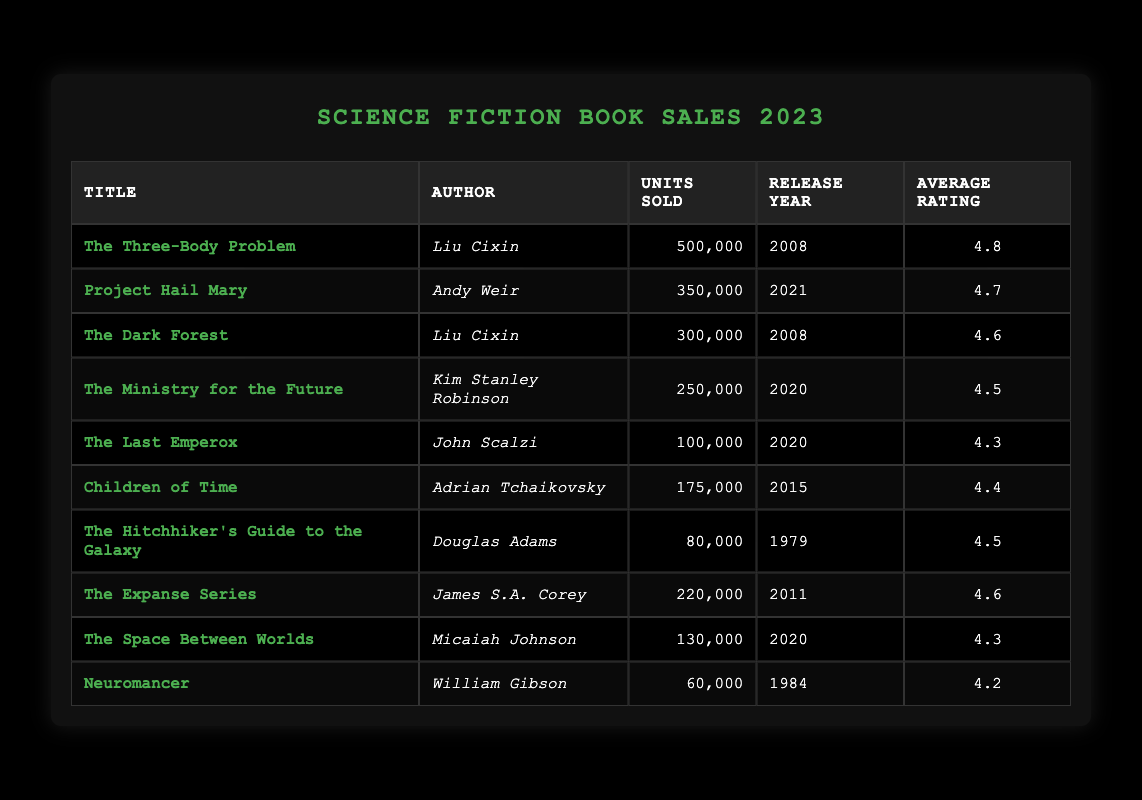What is the title of the highest-selling science fiction book in 2023? By reviewing the "Units Sold" column, "The Three-Body Problem" has the highest number of units sold at 500,000.
Answer: The Three-Body Problem Who is the author of "The Dark Forest"? The table lists "The Dark Forest" under the "Title" column, and the corresponding author listed is Liu Cixin.
Answer: Liu Cixin How many units were sold for "Project Hail Mary"? The "Units Sold" column shows that "Project Hail Mary" sold 350,000 units.
Answer: 350,000 What is the average rating of "The Last Emperox"? The table lists "The Last Emperox" with an average rating of 4.3 in the "Average Rating" column.
Answer: 4.3 Which book has sold fewer units: "The Hitchhiker's Guide to the Galaxy" or "Neuromancer"? By comparing the units sold, "The Hitchhiker's Guide to the Galaxy" sold 80,000 units, while "Neuromancer" sold 60,000 units. "Neuromancer" has sold fewer units.
Answer: Neuromancer What is the total number of units sold by books authored by Liu Cixin? Liu Cixin authored "The Three-Body Problem" (500,000 units) and "The Dark Forest" (300,000 units). Adding these gives 500,000 + 300,000 = 800,000 units total.
Answer: 800,000 Is "Children of Time" rated higher than "The Ministry for the Future"? "Children of Time" has an average rating of 4.4, and "The Ministry for the Future" has a rating of 4.5. Since 4.4 < 4.5, it is false that "Children of Time" is rated higher.
Answer: No Which book released in 2020 sold the most units? In the table, the books released in 2020 are "The Ministry for the Future" (250,000 units) and "The Space Between Worlds" (130,000 units). "The Ministry for the Future" has the higher sales among these.
Answer: The Ministry for the Future How many books sold more than 200,000 units? From the table, the books selling more than 200,000 units are "The Three-Body Problem" (500,000), "Project Hail Mary" (350,000), "The Dark Forest" (300,000), and "The Ministry for the Future" (250,000). That totals 4 books.
Answer: 4 What is the difference in average rating between "The Expanse Series" and "Children of Time"? "The Expanse Series" has an average rating of 4.6, while "Children of Time" has a rating of 4.4. The difference is 4.6 - 4.4 = 0.2.
Answer: 0.2 